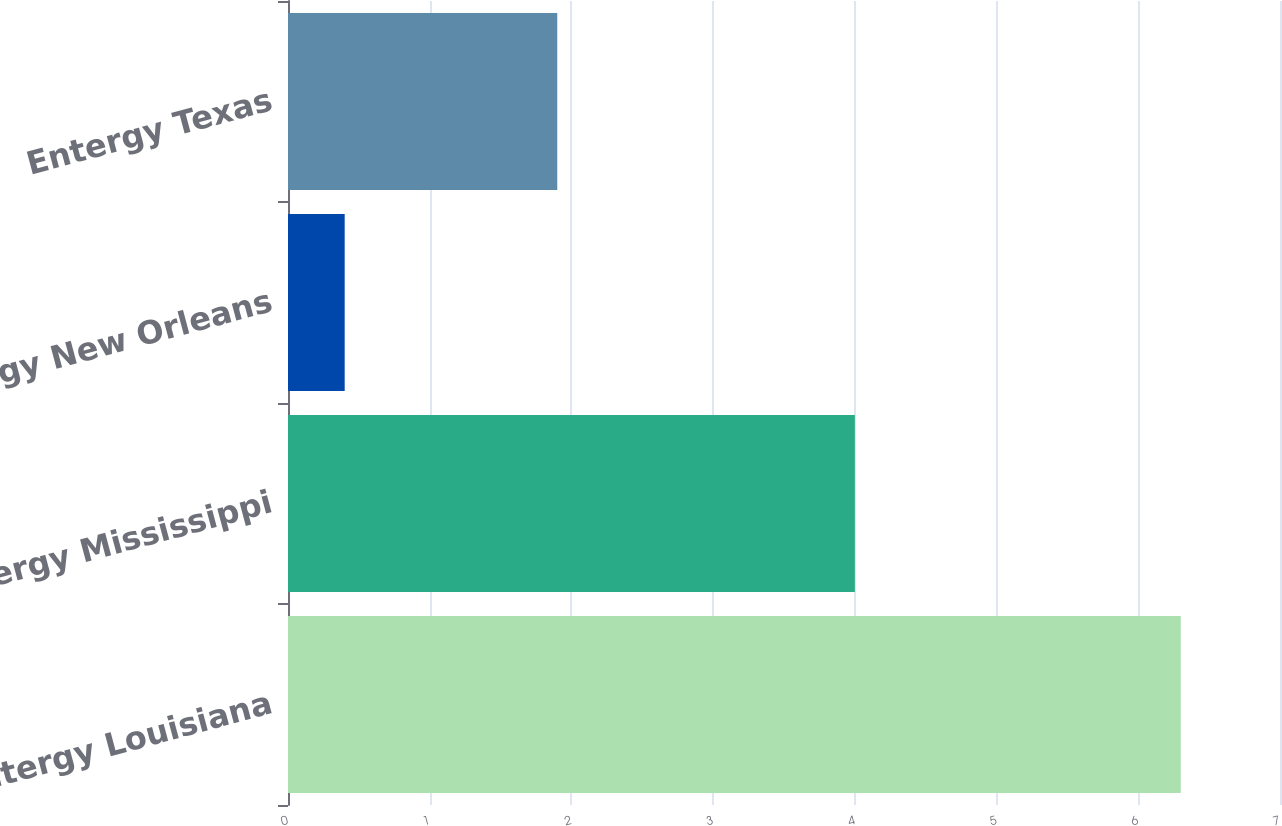Convert chart to OTSL. <chart><loc_0><loc_0><loc_500><loc_500><bar_chart><fcel>Entergy Louisiana<fcel>Entergy Mississippi<fcel>Entergy New Orleans<fcel>Entergy Texas<nl><fcel>6.3<fcel>4<fcel>0.4<fcel>1.9<nl></chart> 